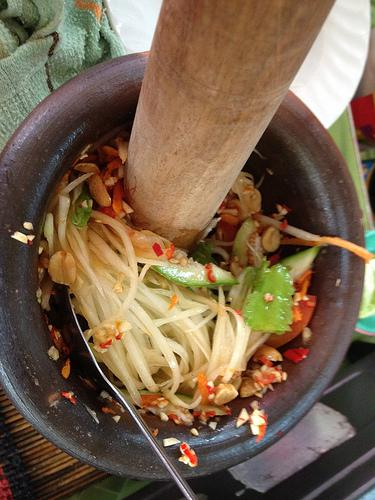Question: what is this food?
Choices:
A. Pasta.
B. Spaghetti.
C. Lasagna.
D. Noodles.
Answer with the letter. Answer: D Question: who took the picture?
Choices:
A. I did.
B. Man.
C. She did.
D. He did.
Answer with the letter. Answer: B Question: what is brown?
Choices:
A. Dirt.
B. Pole in bowl.
C. The path.
D. My car.
Answer with the letter. Answer: B 